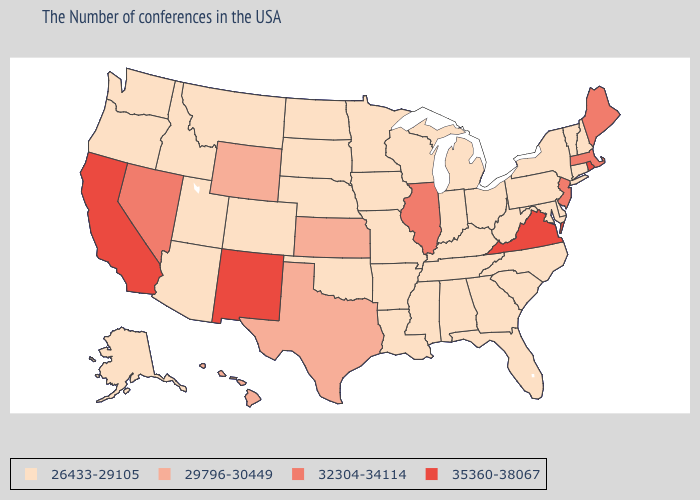What is the lowest value in states that border Connecticut?
Concise answer only. 26433-29105. Does North Dakota have the same value as New Mexico?
Concise answer only. No. Name the states that have a value in the range 26433-29105?
Concise answer only. New Hampshire, Vermont, Connecticut, New York, Delaware, Maryland, Pennsylvania, North Carolina, South Carolina, West Virginia, Ohio, Florida, Georgia, Michigan, Kentucky, Indiana, Alabama, Tennessee, Wisconsin, Mississippi, Louisiana, Missouri, Arkansas, Minnesota, Iowa, Nebraska, Oklahoma, South Dakota, North Dakota, Colorado, Utah, Montana, Arizona, Idaho, Washington, Oregon, Alaska. What is the value of Oregon?
Keep it brief. 26433-29105. Name the states that have a value in the range 35360-38067?
Be succinct. Rhode Island, Virginia, New Mexico, California. What is the lowest value in the USA?
Be succinct. 26433-29105. Which states have the lowest value in the Northeast?
Concise answer only. New Hampshire, Vermont, Connecticut, New York, Pennsylvania. What is the value of Iowa?
Write a very short answer. 26433-29105. Is the legend a continuous bar?
Give a very brief answer. No. What is the highest value in states that border West Virginia?
Concise answer only. 35360-38067. Does Virginia have the lowest value in the USA?
Quick response, please. No. What is the value of Maryland?
Answer briefly. 26433-29105. What is the value of Texas?
Answer briefly. 29796-30449. What is the value of Michigan?
Write a very short answer. 26433-29105. What is the highest value in the USA?
Concise answer only. 35360-38067. 